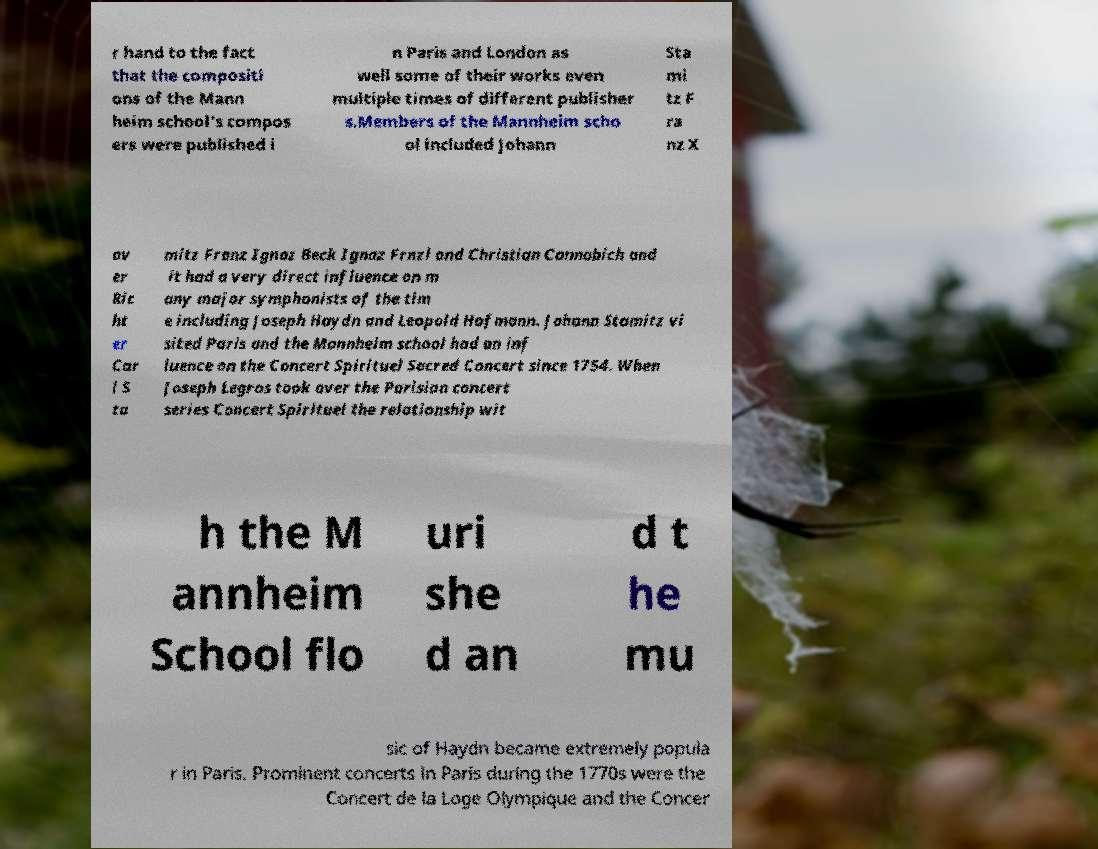Please identify and transcribe the text found in this image. r hand to the fact that the compositi ons of the Mann heim school's compos ers were published i n Paris and London as well some of their works even multiple times of different publisher s.Members of the Mannheim scho ol included Johann Sta mi tz F ra nz X av er Ric ht er Car l S ta mitz Franz Ignaz Beck Ignaz Frnzl and Christian Cannabich and it had a very direct influence on m any major symphonists of the tim e including Joseph Haydn and Leopold Hofmann. Johann Stamitz vi sited Paris and the Mannheim school had an inf luence on the Concert Spirituel Sacred Concert since 1754. When Joseph Legros took over the Parisian concert series Concert Spirituel the relationship wit h the M annheim School flo uri she d an d t he mu sic of Haydn became extremely popula r in Paris. Prominent concerts in Paris during the 1770s were the Concert de la Loge Olympique and the Concer 